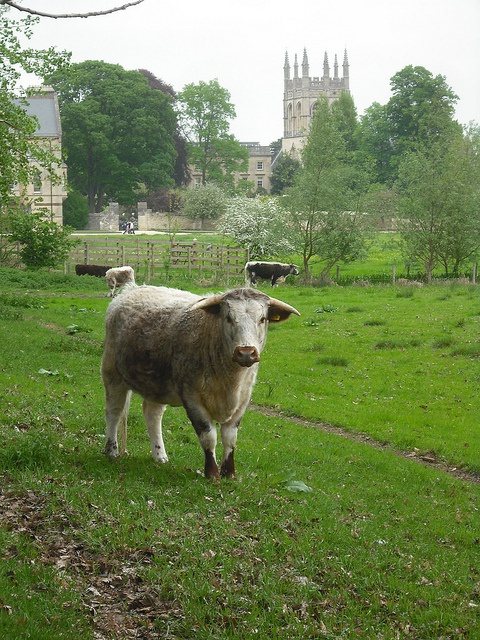Describe the objects in this image and their specific colors. I can see cow in gray, black, darkgreen, and darkgray tones, cow in gray, black, darkgreen, and darkgray tones, and cow in gray, black, and darkgreen tones in this image. 